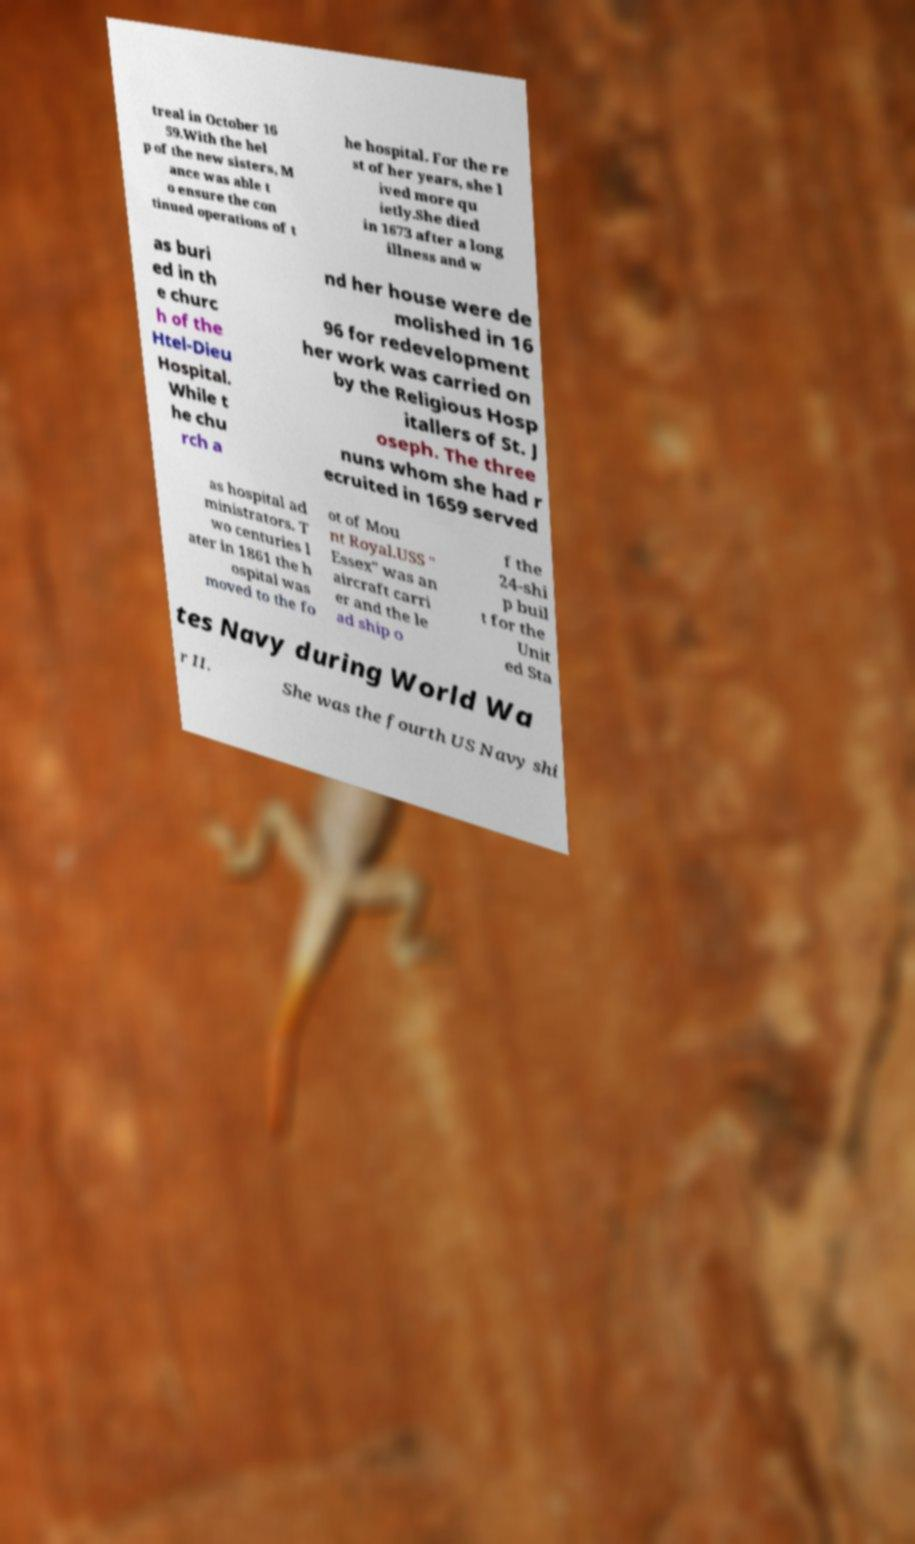Could you extract and type out the text from this image? treal in October 16 59.With the hel p of the new sisters, M ance was able t o ensure the con tinued operations of t he hospital. For the re st of her years, she l ived more qu ietly.She died in 1673 after a long illness and w as buri ed in th e churc h of the Htel-Dieu Hospital. While t he chu rch a nd her house were de molished in 16 96 for redevelopment her work was carried on by the Religious Hosp itallers of St. J oseph. The three nuns whom she had r ecruited in 1659 served as hospital ad ministrators. T wo centuries l ater in 1861 the h ospital was moved to the fo ot of Mou nt Royal.USS " Essex" was an aircraft carri er and the le ad ship o f the 24-shi p buil t for the Unit ed Sta tes Navy during World Wa r II. She was the fourth US Navy shi 